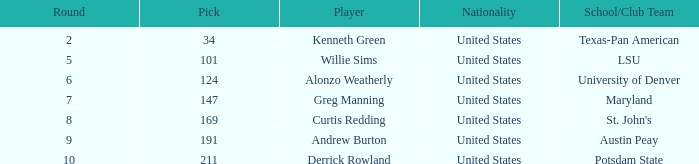What is the typical pick when the round was under 6 for kenneth green? 34.0. 